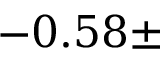<formula> <loc_0><loc_0><loc_500><loc_500>- 0 . 5 8 \pm</formula> 